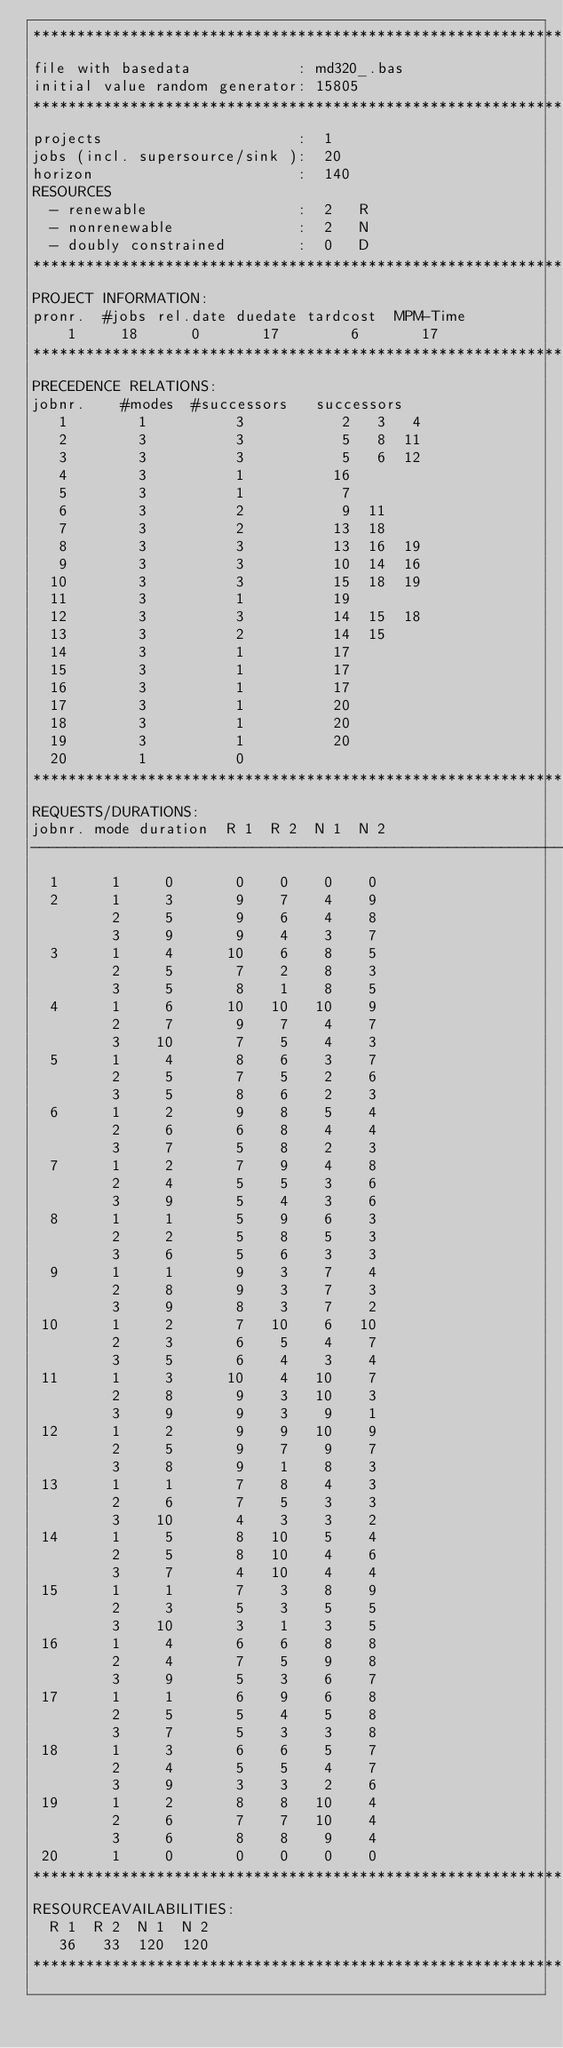Convert code to text. <code><loc_0><loc_0><loc_500><loc_500><_ObjectiveC_>************************************************************************
file with basedata            : md320_.bas
initial value random generator: 15805
************************************************************************
projects                      :  1
jobs (incl. supersource/sink ):  20
horizon                       :  140
RESOURCES
  - renewable                 :  2   R
  - nonrenewable              :  2   N
  - doubly constrained        :  0   D
************************************************************************
PROJECT INFORMATION:
pronr.  #jobs rel.date duedate tardcost  MPM-Time
    1     18      0       17        6       17
************************************************************************
PRECEDENCE RELATIONS:
jobnr.    #modes  #successors   successors
   1        1          3           2   3   4
   2        3          3           5   8  11
   3        3          3           5   6  12
   4        3          1          16
   5        3          1           7
   6        3          2           9  11
   7        3          2          13  18
   8        3          3          13  16  19
   9        3          3          10  14  16
  10        3          3          15  18  19
  11        3          1          19
  12        3          3          14  15  18
  13        3          2          14  15
  14        3          1          17
  15        3          1          17
  16        3          1          17
  17        3          1          20
  18        3          1          20
  19        3          1          20
  20        1          0        
************************************************************************
REQUESTS/DURATIONS:
jobnr. mode duration  R 1  R 2  N 1  N 2
------------------------------------------------------------------------
  1      1     0       0    0    0    0
  2      1     3       9    7    4    9
         2     5       9    6    4    8
         3     9       9    4    3    7
  3      1     4      10    6    8    5
         2     5       7    2    8    3
         3     5       8    1    8    5
  4      1     6      10   10   10    9
         2     7       9    7    4    7
         3    10       7    5    4    3
  5      1     4       8    6    3    7
         2     5       7    5    2    6
         3     5       8    6    2    3
  6      1     2       9    8    5    4
         2     6       6    8    4    4
         3     7       5    8    2    3
  7      1     2       7    9    4    8
         2     4       5    5    3    6
         3     9       5    4    3    6
  8      1     1       5    9    6    3
         2     2       5    8    5    3
         3     6       5    6    3    3
  9      1     1       9    3    7    4
         2     8       9    3    7    3
         3     9       8    3    7    2
 10      1     2       7   10    6   10
         2     3       6    5    4    7
         3     5       6    4    3    4
 11      1     3      10    4   10    7
         2     8       9    3   10    3
         3     9       9    3    9    1
 12      1     2       9    9   10    9
         2     5       9    7    9    7
         3     8       9    1    8    3
 13      1     1       7    8    4    3
         2     6       7    5    3    3
         3    10       4    3    3    2
 14      1     5       8   10    5    4
         2     5       8   10    4    6
         3     7       4   10    4    4
 15      1     1       7    3    8    9
         2     3       5    3    5    5
         3    10       3    1    3    5
 16      1     4       6    6    8    8
         2     4       7    5    9    8
         3     9       5    3    6    7
 17      1     1       6    9    6    8
         2     5       5    4    5    8
         3     7       5    3    3    8
 18      1     3       6    6    5    7
         2     4       5    5    4    7
         3     9       3    3    2    6
 19      1     2       8    8   10    4
         2     6       7    7   10    4
         3     6       8    8    9    4
 20      1     0       0    0    0    0
************************************************************************
RESOURCEAVAILABILITIES:
  R 1  R 2  N 1  N 2
   36   33  120  120
************************************************************************
</code> 